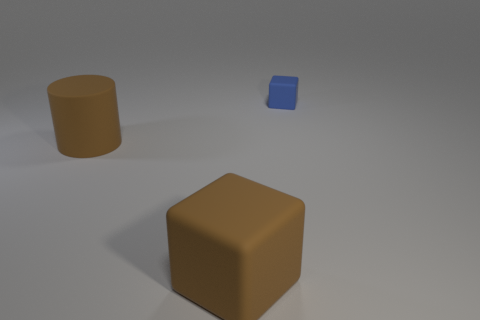Is there anything else that has the same size as the blue object?
Your answer should be very brief. No. Are there fewer tiny matte objects that are left of the tiny thing than large blocks?
Offer a terse response. Yes. There is a blue thing that is made of the same material as the brown cylinder; what shape is it?
Your response must be concise. Cube. How many shiny things are either small cubes or brown cylinders?
Your answer should be very brief. 0. Are there an equal number of matte cylinders that are right of the small blue matte cube and metallic things?
Your answer should be very brief. Yes. There is a rubber thing left of the large cube; does it have the same color as the large block?
Your answer should be compact. Yes. There is a cube that is in front of the tiny thing; are there any things to the right of it?
Make the answer very short. Yes. Are the large brown cylinder and the big brown block made of the same material?
Offer a very short reply. Yes. There is a object that is on the left side of the small blue rubber object and behind the brown matte cube; what is its shape?
Your answer should be compact. Cylinder. There is a rubber cube behind the rubber block in front of the small blue cube; what is its size?
Offer a very short reply. Small. 